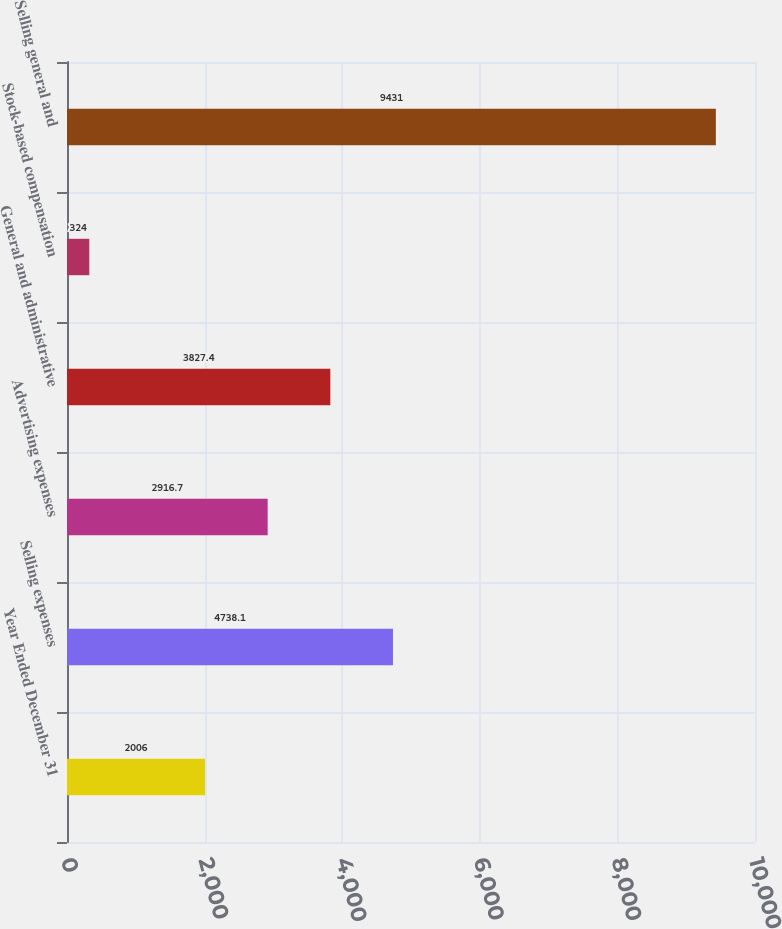<chart> <loc_0><loc_0><loc_500><loc_500><bar_chart><fcel>Year Ended December 31<fcel>Selling expenses<fcel>Advertising expenses<fcel>General and administrative<fcel>Stock-based compensation<fcel>Selling general and<nl><fcel>2006<fcel>4738.1<fcel>2916.7<fcel>3827.4<fcel>324<fcel>9431<nl></chart> 